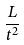<formula> <loc_0><loc_0><loc_500><loc_500>\frac { L } { t ^ { 2 } }</formula> 